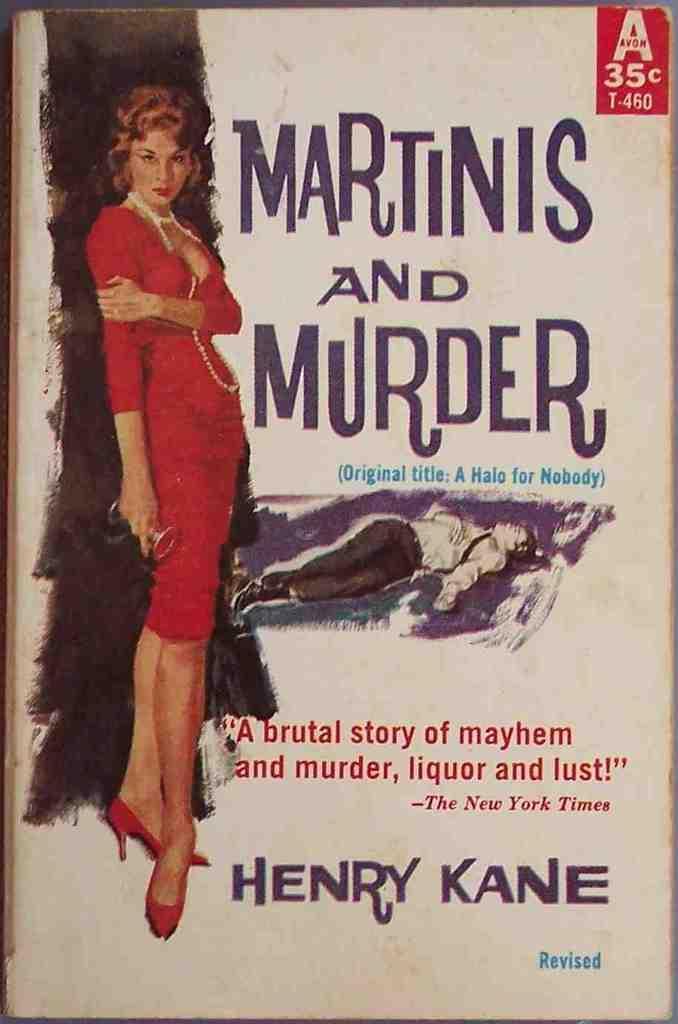Describe this image in one or two sentences. In the image it seems like a cover page of a book, there are depictions of two people and beside the depictions there are names and some text. 